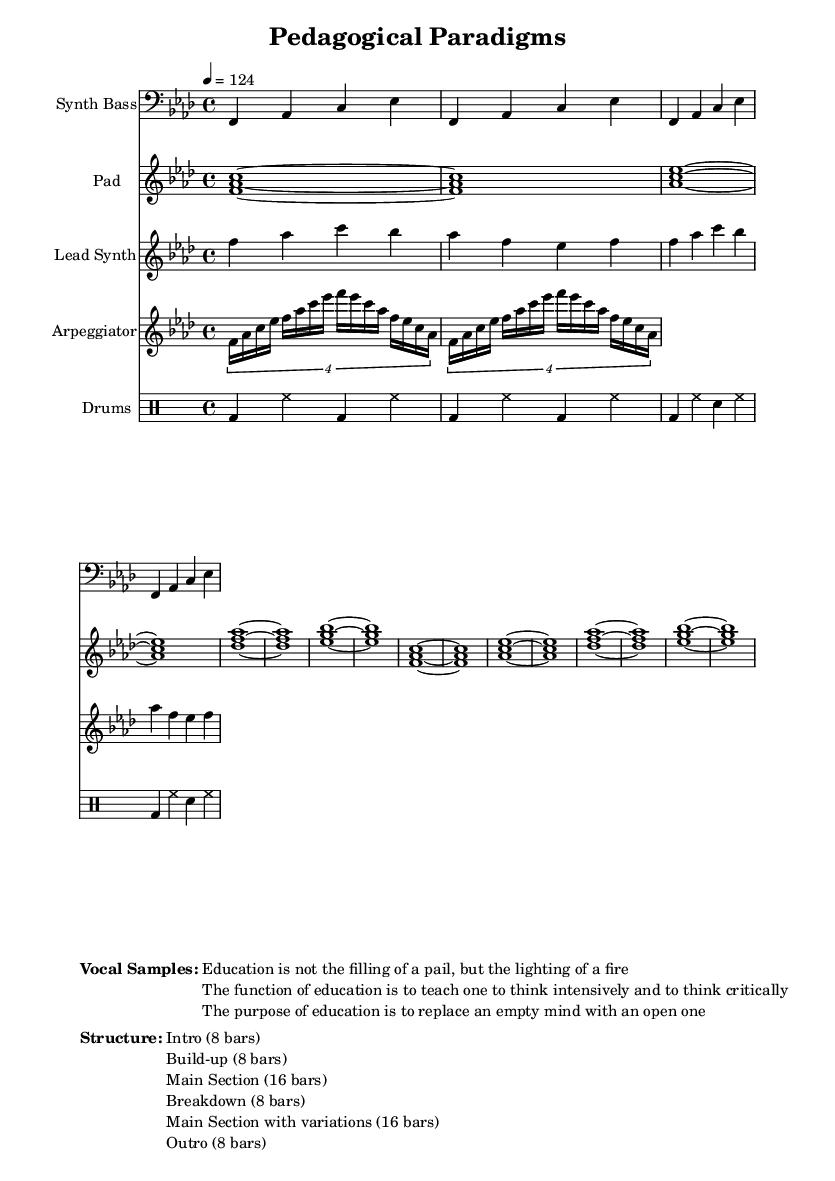What is the key signature of this music? The key signature is F minor, indicated by four flats (B♭, E♭, A♭, and D♭). You can identify this by looking at the key signature section of the score, which is placed at the beginning of the staff lines.
Answer: F minor What is the time signature of this music? The time signature is 4/4, which means there are four beats per measure and the quarter note receives one beat. This is evident from the time signature marking found at the beginning of the score.
Answer: 4/4 What is the tempo marking of this music? The tempo marking is 124 beats per minute, indicated in the score. The tempo is provided at the beginning of the score with the instruction "4 = 124".
Answer: 124 How many bars are in the breakdown section? The breakdown section consists of 8 bars, which is explicitly stated in the structure section of the score. By counting the bars listed, it confirms there are 8 for the breakdown.
Answer: 8 What are the vocal sample quotes about? The vocal samples discuss education, specifically emphasizing concepts like inspiration over mere knowledge acquisition, critical thinking, and the transformation of mindsets. This can be deduced from the content of the quotes listed under the vocal samples in the score.
Answer: Educational philosophy What is the instrument used for bass in this composition? The instrument designated for bass in this score is a Synth Bass, confirmed by the label above that staff in the score where the bass part is notated.
Answer: Synth Bass How many bars form the main section with variations? The main section with variations is made up of 16 bars, as indicated in the structure section of the score. This reflects the length specified for that part of the composition.
Answer: 16 